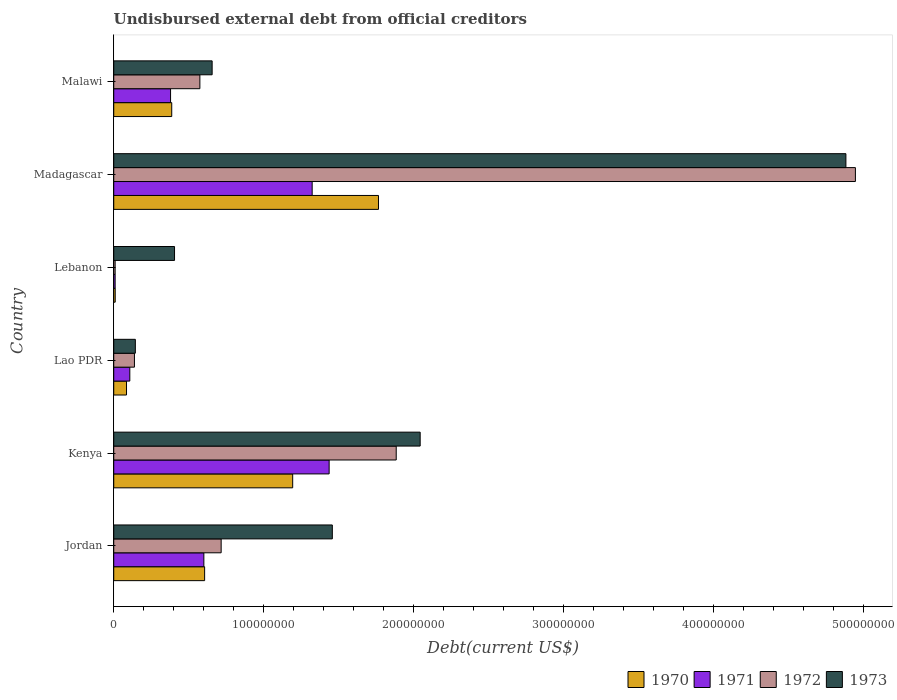How many different coloured bars are there?
Offer a terse response. 4. Are the number of bars on each tick of the Y-axis equal?
Keep it short and to the point. Yes. How many bars are there on the 2nd tick from the top?
Your response must be concise. 4. What is the label of the 2nd group of bars from the top?
Provide a succinct answer. Madagascar. In how many cases, is the number of bars for a given country not equal to the number of legend labels?
Provide a succinct answer. 0. What is the total debt in 1970 in Kenya?
Keep it short and to the point. 1.19e+08. Across all countries, what is the maximum total debt in 1970?
Keep it short and to the point. 1.76e+08. Across all countries, what is the minimum total debt in 1971?
Provide a succinct answer. 9.32e+05. In which country was the total debt in 1970 maximum?
Your answer should be compact. Madagascar. In which country was the total debt in 1971 minimum?
Provide a short and direct response. Lebanon. What is the total total debt in 1970 in the graph?
Give a very brief answer. 4.05e+08. What is the difference between the total debt in 1972 in Lao PDR and that in Madagascar?
Give a very brief answer. -4.81e+08. What is the difference between the total debt in 1971 in Kenya and the total debt in 1972 in Lebanon?
Your response must be concise. 1.43e+08. What is the average total debt in 1972 per country?
Ensure brevity in your answer.  1.38e+08. What is the difference between the total debt in 1970 and total debt in 1973 in Jordan?
Keep it short and to the point. -8.51e+07. What is the ratio of the total debt in 1971 in Jordan to that in Lebanon?
Make the answer very short. 64.46. What is the difference between the highest and the second highest total debt in 1970?
Make the answer very short. 5.72e+07. What is the difference between the highest and the lowest total debt in 1973?
Your answer should be very brief. 4.74e+08. In how many countries, is the total debt in 1972 greater than the average total debt in 1972 taken over all countries?
Keep it short and to the point. 2. What does the 3rd bar from the top in Malawi represents?
Provide a short and direct response. 1971. Are all the bars in the graph horizontal?
Give a very brief answer. Yes. How many countries are there in the graph?
Your answer should be very brief. 6. What is the difference between two consecutive major ticks on the X-axis?
Ensure brevity in your answer.  1.00e+08. Are the values on the major ticks of X-axis written in scientific E-notation?
Provide a succinct answer. No. Does the graph contain any zero values?
Your answer should be compact. No. Where does the legend appear in the graph?
Make the answer very short. Bottom right. What is the title of the graph?
Make the answer very short. Undisbursed external debt from official creditors. Does "1986" appear as one of the legend labels in the graph?
Your answer should be very brief. No. What is the label or title of the X-axis?
Your answer should be compact. Debt(current US$). What is the Debt(current US$) of 1970 in Jordan?
Offer a terse response. 6.06e+07. What is the Debt(current US$) in 1971 in Jordan?
Ensure brevity in your answer.  6.01e+07. What is the Debt(current US$) in 1972 in Jordan?
Give a very brief answer. 7.16e+07. What is the Debt(current US$) in 1973 in Jordan?
Give a very brief answer. 1.46e+08. What is the Debt(current US$) of 1970 in Kenya?
Keep it short and to the point. 1.19e+08. What is the Debt(current US$) in 1971 in Kenya?
Provide a succinct answer. 1.44e+08. What is the Debt(current US$) of 1972 in Kenya?
Your response must be concise. 1.88e+08. What is the Debt(current US$) in 1973 in Kenya?
Give a very brief answer. 2.04e+08. What is the Debt(current US$) in 1970 in Lao PDR?
Ensure brevity in your answer.  8.52e+06. What is the Debt(current US$) in 1971 in Lao PDR?
Your answer should be compact. 1.07e+07. What is the Debt(current US$) of 1972 in Lao PDR?
Give a very brief answer. 1.38e+07. What is the Debt(current US$) of 1973 in Lao PDR?
Offer a very short reply. 1.44e+07. What is the Debt(current US$) of 1970 in Lebanon?
Offer a very short reply. 9.80e+05. What is the Debt(current US$) in 1971 in Lebanon?
Your response must be concise. 9.32e+05. What is the Debt(current US$) in 1972 in Lebanon?
Provide a short and direct response. 9.32e+05. What is the Debt(current US$) in 1973 in Lebanon?
Provide a short and direct response. 4.05e+07. What is the Debt(current US$) in 1970 in Madagascar?
Provide a short and direct response. 1.76e+08. What is the Debt(current US$) in 1971 in Madagascar?
Give a very brief answer. 1.32e+08. What is the Debt(current US$) of 1972 in Madagascar?
Ensure brevity in your answer.  4.94e+08. What is the Debt(current US$) in 1973 in Madagascar?
Your answer should be compact. 4.88e+08. What is the Debt(current US$) in 1970 in Malawi?
Your response must be concise. 3.87e+07. What is the Debt(current US$) of 1971 in Malawi?
Provide a succinct answer. 3.79e+07. What is the Debt(current US$) of 1972 in Malawi?
Provide a short and direct response. 5.74e+07. What is the Debt(current US$) in 1973 in Malawi?
Offer a very short reply. 6.56e+07. Across all countries, what is the maximum Debt(current US$) of 1970?
Make the answer very short. 1.76e+08. Across all countries, what is the maximum Debt(current US$) in 1971?
Offer a very short reply. 1.44e+08. Across all countries, what is the maximum Debt(current US$) in 1972?
Your answer should be compact. 4.94e+08. Across all countries, what is the maximum Debt(current US$) of 1973?
Your response must be concise. 4.88e+08. Across all countries, what is the minimum Debt(current US$) of 1970?
Give a very brief answer. 9.80e+05. Across all countries, what is the minimum Debt(current US$) of 1971?
Your response must be concise. 9.32e+05. Across all countries, what is the minimum Debt(current US$) of 1972?
Ensure brevity in your answer.  9.32e+05. Across all countries, what is the minimum Debt(current US$) of 1973?
Your answer should be very brief. 1.44e+07. What is the total Debt(current US$) in 1970 in the graph?
Provide a short and direct response. 4.05e+08. What is the total Debt(current US$) in 1971 in the graph?
Offer a very short reply. 3.85e+08. What is the total Debt(current US$) of 1972 in the graph?
Keep it short and to the point. 8.27e+08. What is the total Debt(current US$) of 1973 in the graph?
Provide a succinct answer. 9.59e+08. What is the difference between the Debt(current US$) of 1970 in Jordan and that in Kenya?
Ensure brevity in your answer.  -5.87e+07. What is the difference between the Debt(current US$) in 1971 in Jordan and that in Kenya?
Your response must be concise. -8.35e+07. What is the difference between the Debt(current US$) of 1972 in Jordan and that in Kenya?
Provide a succinct answer. -1.17e+08. What is the difference between the Debt(current US$) in 1973 in Jordan and that in Kenya?
Your answer should be compact. -5.86e+07. What is the difference between the Debt(current US$) of 1970 in Jordan and that in Lao PDR?
Offer a very short reply. 5.21e+07. What is the difference between the Debt(current US$) of 1971 in Jordan and that in Lao PDR?
Give a very brief answer. 4.94e+07. What is the difference between the Debt(current US$) of 1972 in Jordan and that in Lao PDR?
Give a very brief answer. 5.78e+07. What is the difference between the Debt(current US$) in 1973 in Jordan and that in Lao PDR?
Offer a terse response. 1.31e+08. What is the difference between the Debt(current US$) of 1970 in Jordan and that in Lebanon?
Give a very brief answer. 5.96e+07. What is the difference between the Debt(current US$) in 1971 in Jordan and that in Lebanon?
Provide a succinct answer. 5.91e+07. What is the difference between the Debt(current US$) in 1972 in Jordan and that in Lebanon?
Offer a very short reply. 7.07e+07. What is the difference between the Debt(current US$) in 1973 in Jordan and that in Lebanon?
Provide a succinct answer. 1.05e+08. What is the difference between the Debt(current US$) of 1970 in Jordan and that in Madagascar?
Your response must be concise. -1.16e+08. What is the difference between the Debt(current US$) of 1971 in Jordan and that in Madagascar?
Keep it short and to the point. -7.22e+07. What is the difference between the Debt(current US$) in 1972 in Jordan and that in Madagascar?
Ensure brevity in your answer.  -4.23e+08. What is the difference between the Debt(current US$) in 1973 in Jordan and that in Madagascar?
Ensure brevity in your answer.  -3.42e+08. What is the difference between the Debt(current US$) in 1970 in Jordan and that in Malawi?
Ensure brevity in your answer.  2.19e+07. What is the difference between the Debt(current US$) of 1971 in Jordan and that in Malawi?
Your answer should be compact. 2.22e+07. What is the difference between the Debt(current US$) of 1972 in Jordan and that in Malawi?
Offer a terse response. 1.42e+07. What is the difference between the Debt(current US$) of 1973 in Jordan and that in Malawi?
Your answer should be compact. 8.01e+07. What is the difference between the Debt(current US$) of 1970 in Kenya and that in Lao PDR?
Your response must be concise. 1.11e+08. What is the difference between the Debt(current US$) in 1971 in Kenya and that in Lao PDR?
Your answer should be compact. 1.33e+08. What is the difference between the Debt(current US$) in 1972 in Kenya and that in Lao PDR?
Offer a very short reply. 1.75e+08. What is the difference between the Debt(current US$) of 1973 in Kenya and that in Lao PDR?
Ensure brevity in your answer.  1.90e+08. What is the difference between the Debt(current US$) in 1970 in Kenya and that in Lebanon?
Ensure brevity in your answer.  1.18e+08. What is the difference between the Debt(current US$) of 1971 in Kenya and that in Lebanon?
Your answer should be very brief. 1.43e+08. What is the difference between the Debt(current US$) of 1972 in Kenya and that in Lebanon?
Offer a very short reply. 1.87e+08. What is the difference between the Debt(current US$) of 1973 in Kenya and that in Lebanon?
Provide a succinct answer. 1.64e+08. What is the difference between the Debt(current US$) in 1970 in Kenya and that in Madagascar?
Your answer should be very brief. -5.72e+07. What is the difference between the Debt(current US$) of 1971 in Kenya and that in Madagascar?
Your answer should be compact. 1.13e+07. What is the difference between the Debt(current US$) in 1972 in Kenya and that in Madagascar?
Provide a succinct answer. -3.06e+08. What is the difference between the Debt(current US$) in 1973 in Kenya and that in Madagascar?
Offer a terse response. -2.84e+08. What is the difference between the Debt(current US$) in 1970 in Kenya and that in Malawi?
Provide a succinct answer. 8.06e+07. What is the difference between the Debt(current US$) of 1971 in Kenya and that in Malawi?
Give a very brief answer. 1.06e+08. What is the difference between the Debt(current US$) of 1972 in Kenya and that in Malawi?
Keep it short and to the point. 1.31e+08. What is the difference between the Debt(current US$) of 1973 in Kenya and that in Malawi?
Your answer should be compact. 1.39e+08. What is the difference between the Debt(current US$) of 1970 in Lao PDR and that in Lebanon?
Your answer should be compact. 7.54e+06. What is the difference between the Debt(current US$) of 1971 in Lao PDR and that in Lebanon?
Your answer should be very brief. 9.78e+06. What is the difference between the Debt(current US$) of 1972 in Lao PDR and that in Lebanon?
Provide a short and direct response. 1.29e+07. What is the difference between the Debt(current US$) of 1973 in Lao PDR and that in Lebanon?
Your answer should be very brief. -2.61e+07. What is the difference between the Debt(current US$) of 1970 in Lao PDR and that in Madagascar?
Offer a very short reply. -1.68e+08. What is the difference between the Debt(current US$) of 1971 in Lao PDR and that in Madagascar?
Provide a short and direct response. -1.22e+08. What is the difference between the Debt(current US$) of 1972 in Lao PDR and that in Madagascar?
Offer a very short reply. -4.81e+08. What is the difference between the Debt(current US$) of 1973 in Lao PDR and that in Madagascar?
Your answer should be very brief. -4.74e+08. What is the difference between the Debt(current US$) in 1970 in Lao PDR and that in Malawi?
Make the answer very short. -3.01e+07. What is the difference between the Debt(current US$) of 1971 in Lao PDR and that in Malawi?
Give a very brief answer. -2.72e+07. What is the difference between the Debt(current US$) in 1972 in Lao PDR and that in Malawi?
Keep it short and to the point. -4.36e+07. What is the difference between the Debt(current US$) in 1973 in Lao PDR and that in Malawi?
Offer a very short reply. -5.12e+07. What is the difference between the Debt(current US$) of 1970 in Lebanon and that in Madagascar?
Ensure brevity in your answer.  -1.76e+08. What is the difference between the Debt(current US$) in 1971 in Lebanon and that in Madagascar?
Provide a succinct answer. -1.31e+08. What is the difference between the Debt(current US$) in 1972 in Lebanon and that in Madagascar?
Provide a succinct answer. -4.94e+08. What is the difference between the Debt(current US$) of 1973 in Lebanon and that in Madagascar?
Make the answer very short. -4.48e+08. What is the difference between the Debt(current US$) of 1970 in Lebanon and that in Malawi?
Provide a short and direct response. -3.77e+07. What is the difference between the Debt(current US$) in 1971 in Lebanon and that in Malawi?
Your response must be concise. -3.70e+07. What is the difference between the Debt(current US$) in 1972 in Lebanon and that in Malawi?
Your answer should be compact. -5.65e+07. What is the difference between the Debt(current US$) in 1973 in Lebanon and that in Malawi?
Offer a very short reply. -2.51e+07. What is the difference between the Debt(current US$) in 1970 in Madagascar and that in Malawi?
Your answer should be compact. 1.38e+08. What is the difference between the Debt(current US$) in 1971 in Madagascar and that in Malawi?
Provide a short and direct response. 9.44e+07. What is the difference between the Debt(current US$) of 1972 in Madagascar and that in Malawi?
Your response must be concise. 4.37e+08. What is the difference between the Debt(current US$) of 1973 in Madagascar and that in Malawi?
Provide a succinct answer. 4.23e+08. What is the difference between the Debt(current US$) in 1970 in Jordan and the Debt(current US$) in 1971 in Kenya?
Your response must be concise. -8.30e+07. What is the difference between the Debt(current US$) of 1970 in Jordan and the Debt(current US$) of 1972 in Kenya?
Ensure brevity in your answer.  -1.28e+08. What is the difference between the Debt(current US$) of 1970 in Jordan and the Debt(current US$) of 1973 in Kenya?
Keep it short and to the point. -1.44e+08. What is the difference between the Debt(current US$) of 1971 in Jordan and the Debt(current US$) of 1972 in Kenya?
Offer a very short reply. -1.28e+08. What is the difference between the Debt(current US$) in 1971 in Jordan and the Debt(current US$) in 1973 in Kenya?
Offer a terse response. -1.44e+08. What is the difference between the Debt(current US$) in 1972 in Jordan and the Debt(current US$) in 1973 in Kenya?
Keep it short and to the point. -1.33e+08. What is the difference between the Debt(current US$) of 1970 in Jordan and the Debt(current US$) of 1971 in Lao PDR?
Your answer should be very brief. 4.99e+07. What is the difference between the Debt(current US$) in 1970 in Jordan and the Debt(current US$) in 1972 in Lao PDR?
Provide a succinct answer. 4.68e+07. What is the difference between the Debt(current US$) in 1970 in Jordan and the Debt(current US$) in 1973 in Lao PDR?
Offer a very short reply. 4.62e+07. What is the difference between the Debt(current US$) of 1971 in Jordan and the Debt(current US$) of 1972 in Lao PDR?
Offer a terse response. 4.63e+07. What is the difference between the Debt(current US$) of 1971 in Jordan and the Debt(current US$) of 1973 in Lao PDR?
Give a very brief answer. 4.57e+07. What is the difference between the Debt(current US$) in 1972 in Jordan and the Debt(current US$) in 1973 in Lao PDR?
Ensure brevity in your answer.  5.72e+07. What is the difference between the Debt(current US$) of 1970 in Jordan and the Debt(current US$) of 1971 in Lebanon?
Your answer should be very brief. 5.97e+07. What is the difference between the Debt(current US$) of 1970 in Jordan and the Debt(current US$) of 1972 in Lebanon?
Make the answer very short. 5.97e+07. What is the difference between the Debt(current US$) in 1970 in Jordan and the Debt(current US$) in 1973 in Lebanon?
Provide a short and direct response. 2.01e+07. What is the difference between the Debt(current US$) of 1971 in Jordan and the Debt(current US$) of 1972 in Lebanon?
Give a very brief answer. 5.91e+07. What is the difference between the Debt(current US$) in 1971 in Jordan and the Debt(current US$) in 1973 in Lebanon?
Your answer should be compact. 1.95e+07. What is the difference between the Debt(current US$) in 1972 in Jordan and the Debt(current US$) in 1973 in Lebanon?
Make the answer very short. 3.11e+07. What is the difference between the Debt(current US$) of 1970 in Jordan and the Debt(current US$) of 1971 in Madagascar?
Provide a succinct answer. -7.17e+07. What is the difference between the Debt(current US$) of 1970 in Jordan and the Debt(current US$) of 1972 in Madagascar?
Make the answer very short. -4.34e+08. What is the difference between the Debt(current US$) in 1970 in Jordan and the Debt(current US$) in 1973 in Madagascar?
Provide a short and direct response. -4.28e+08. What is the difference between the Debt(current US$) in 1971 in Jordan and the Debt(current US$) in 1972 in Madagascar?
Offer a very short reply. -4.34e+08. What is the difference between the Debt(current US$) in 1971 in Jordan and the Debt(current US$) in 1973 in Madagascar?
Your answer should be compact. -4.28e+08. What is the difference between the Debt(current US$) in 1972 in Jordan and the Debt(current US$) in 1973 in Madagascar?
Ensure brevity in your answer.  -4.17e+08. What is the difference between the Debt(current US$) in 1970 in Jordan and the Debt(current US$) in 1971 in Malawi?
Your answer should be very brief. 2.27e+07. What is the difference between the Debt(current US$) of 1970 in Jordan and the Debt(current US$) of 1972 in Malawi?
Ensure brevity in your answer.  3.17e+06. What is the difference between the Debt(current US$) of 1970 in Jordan and the Debt(current US$) of 1973 in Malawi?
Your response must be concise. -5.00e+06. What is the difference between the Debt(current US$) in 1971 in Jordan and the Debt(current US$) in 1972 in Malawi?
Provide a short and direct response. 2.65e+06. What is the difference between the Debt(current US$) of 1971 in Jordan and the Debt(current US$) of 1973 in Malawi?
Provide a succinct answer. -5.52e+06. What is the difference between the Debt(current US$) in 1972 in Jordan and the Debt(current US$) in 1973 in Malawi?
Keep it short and to the point. 6.01e+06. What is the difference between the Debt(current US$) in 1970 in Kenya and the Debt(current US$) in 1971 in Lao PDR?
Keep it short and to the point. 1.09e+08. What is the difference between the Debt(current US$) of 1970 in Kenya and the Debt(current US$) of 1972 in Lao PDR?
Offer a very short reply. 1.05e+08. What is the difference between the Debt(current US$) of 1970 in Kenya and the Debt(current US$) of 1973 in Lao PDR?
Keep it short and to the point. 1.05e+08. What is the difference between the Debt(current US$) in 1971 in Kenya and the Debt(current US$) in 1972 in Lao PDR?
Ensure brevity in your answer.  1.30e+08. What is the difference between the Debt(current US$) in 1971 in Kenya and the Debt(current US$) in 1973 in Lao PDR?
Keep it short and to the point. 1.29e+08. What is the difference between the Debt(current US$) of 1972 in Kenya and the Debt(current US$) of 1973 in Lao PDR?
Ensure brevity in your answer.  1.74e+08. What is the difference between the Debt(current US$) of 1970 in Kenya and the Debt(current US$) of 1971 in Lebanon?
Provide a succinct answer. 1.18e+08. What is the difference between the Debt(current US$) in 1970 in Kenya and the Debt(current US$) in 1972 in Lebanon?
Offer a terse response. 1.18e+08. What is the difference between the Debt(current US$) in 1970 in Kenya and the Debt(current US$) in 1973 in Lebanon?
Your answer should be compact. 7.88e+07. What is the difference between the Debt(current US$) in 1971 in Kenya and the Debt(current US$) in 1972 in Lebanon?
Your response must be concise. 1.43e+08. What is the difference between the Debt(current US$) of 1971 in Kenya and the Debt(current US$) of 1973 in Lebanon?
Provide a succinct answer. 1.03e+08. What is the difference between the Debt(current US$) in 1972 in Kenya and the Debt(current US$) in 1973 in Lebanon?
Your answer should be very brief. 1.48e+08. What is the difference between the Debt(current US$) in 1970 in Kenya and the Debt(current US$) in 1971 in Madagascar?
Your response must be concise. -1.30e+07. What is the difference between the Debt(current US$) in 1970 in Kenya and the Debt(current US$) in 1972 in Madagascar?
Your answer should be very brief. -3.75e+08. What is the difference between the Debt(current US$) in 1970 in Kenya and the Debt(current US$) in 1973 in Madagascar?
Offer a very short reply. -3.69e+08. What is the difference between the Debt(current US$) of 1971 in Kenya and the Debt(current US$) of 1972 in Madagascar?
Keep it short and to the point. -3.51e+08. What is the difference between the Debt(current US$) of 1971 in Kenya and the Debt(current US$) of 1973 in Madagascar?
Your answer should be compact. -3.45e+08. What is the difference between the Debt(current US$) in 1972 in Kenya and the Debt(current US$) in 1973 in Madagascar?
Offer a very short reply. -3.00e+08. What is the difference between the Debt(current US$) of 1970 in Kenya and the Debt(current US$) of 1971 in Malawi?
Make the answer very short. 8.14e+07. What is the difference between the Debt(current US$) in 1970 in Kenya and the Debt(current US$) in 1972 in Malawi?
Give a very brief answer. 6.19e+07. What is the difference between the Debt(current US$) in 1970 in Kenya and the Debt(current US$) in 1973 in Malawi?
Offer a very short reply. 5.37e+07. What is the difference between the Debt(current US$) of 1971 in Kenya and the Debt(current US$) of 1972 in Malawi?
Make the answer very short. 8.62e+07. What is the difference between the Debt(current US$) of 1971 in Kenya and the Debt(current US$) of 1973 in Malawi?
Offer a terse response. 7.80e+07. What is the difference between the Debt(current US$) in 1972 in Kenya and the Debt(current US$) in 1973 in Malawi?
Your answer should be very brief. 1.23e+08. What is the difference between the Debt(current US$) of 1970 in Lao PDR and the Debt(current US$) of 1971 in Lebanon?
Keep it short and to the point. 7.59e+06. What is the difference between the Debt(current US$) of 1970 in Lao PDR and the Debt(current US$) of 1972 in Lebanon?
Your answer should be compact. 7.59e+06. What is the difference between the Debt(current US$) in 1970 in Lao PDR and the Debt(current US$) in 1973 in Lebanon?
Make the answer very short. -3.20e+07. What is the difference between the Debt(current US$) in 1971 in Lao PDR and the Debt(current US$) in 1972 in Lebanon?
Offer a very short reply. 9.78e+06. What is the difference between the Debt(current US$) in 1971 in Lao PDR and the Debt(current US$) in 1973 in Lebanon?
Ensure brevity in your answer.  -2.98e+07. What is the difference between the Debt(current US$) of 1972 in Lao PDR and the Debt(current US$) of 1973 in Lebanon?
Provide a short and direct response. -2.67e+07. What is the difference between the Debt(current US$) in 1970 in Lao PDR and the Debt(current US$) in 1971 in Madagascar?
Provide a succinct answer. -1.24e+08. What is the difference between the Debt(current US$) in 1970 in Lao PDR and the Debt(current US$) in 1972 in Madagascar?
Provide a short and direct response. -4.86e+08. What is the difference between the Debt(current US$) of 1970 in Lao PDR and the Debt(current US$) of 1973 in Madagascar?
Make the answer very short. -4.80e+08. What is the difference between the Debt(current US$) in 1971 in Lao PDR and the Debt(current US$) in 1972 in Madagascar?
Your response must be concise. -4.84e+08. What is the difference between the Debt(current US$) in 1971 in Lao PDR and the Debt(current US$) in 1973 in Madagascar?
Offer a terse response. -4.77e+08. What is the difference between the Debt(current US$) of 1972 in Lao PDR and the Debt(current US$) of 1973 in Madagascar?
Make the answer very short. -4.74e+08. What is the difference between the Debt(current US$) in 1970 in Lao PDR and the Debt(current US$) in 1971 in Malawi?
Offer a very short reply. -2.94e+07. What is the difference between the Debt(current US$) of 1970 in Lao PDR and the Debt(current US$) of 1972 in Malawi?
Your answer should be very brief. -4.89e+07. What is the difference between the Debt(current US$) of 1970 in Lao PDR and the Debt(current US$) of 1973 in Malawi?
Give a very brief answer. -5.71e+07. What is the difference between the Debt(current US$) of 1971 in Lao PDR and the Debt(current US$) of 1972 in Malawi?
Your answer should be compact. -4.67e+07. What is the difference between the Debt(current US$) in 1971 in Lao PDR and the Debt(current US$) in 1973 in Malawi?
Provide a short and direct response. -5.49e+07. What is the difference between the Debt(current US$) of 1972 in Lao PDR and the Debt(current US$) of 1973 in Malawi?
Ensure brevity in your answer.  -5.18e+07. What is the difference between the Debt(current US$) of 1970 in Lebanon and the Debt(current US$) of 1971 in Madagascar?
Your response must be concise. -1.31e+08. What is the difference between the Debt(current US$) of 1970 in Lebanon and the Debt(current US$) of 1972 in Madagascar?
Provide a succinct answer. -4.93e+08. What is the difference between the Debt(current US$) of 1970 in Lebanon and the Debt(current US$) of 1973 in Madagascar?
Your response must be concise. -4.87e+08. What is the difference between the Debt(current US$) in 1971 in Lebanon and the Debt(current US$) in 1972 in Madagascar?
Make the answer very short. -4.94e+08. What is the difference between the Debt(current US$) in 1971 in Lebanon and the Debt(current US$) in 1973 in Madagascar?
Ensure brevity in your answer.  -4.87e+08. What is the difference between the Debt(current US$) of 1972 in Lebanon and the Debt(current US$) of 1973 in Madagascar?
Your answer should be very brief. -4.87e+08. What is the difference between the Debt(current US$) in 1970 in Lebanon and the Debt(current US$) in 1971 in Malawi?
Make the answer very short. -3.69e+07. What is the difference between the Debt(current US$) in 1970 in Lebanon and the Debt(current US$) in 1972 in Malawi?
Provide a succinct answer. -5.64e+07. What is the difference between the Debt(current US$) in 1970 in Lebanon and the Debt(current US$) in 1973 in Malawi?
Your answer should be very brief. -6.46e+07. What is the difference between the Debt(current US$) in 1971 in Lebanon and the Debt(current US$) in 1972 in Malawi?
Provide a succinct answer. -5.65e+07. What is the difference between the Debt(current US$) of 1971 in Lebanon and the Debt(current US$) of 1973 in Malawi?
Offer a terse response. -6.47e+07. What is the difference between the Debt(current US$) of 1972 in Lebanon and the Debt(current US$) of 1973 in Malawi?
Give a very brief answer. -6.47e+07. What is the difference between the Debt(current US$) in 1970 in Madagascar and the Debt(current US$) in 1971 in Malawi?
Provide a succinct answer. 1.39e+08. What is the difference between the Debt(current US$) in 1970 in Madagascar and the Debt(current US$) in 1972 in Malawi?
Offer a very short reply. 1.19e+08. What is the difference between the Debt(current US$) of 1970 in Madagascar and the Debt(current US$) of 1973 in Malawi?
Your answer should be very brief. 1.11e+08. What is the difference between the Debt(current US$) of 1971 in Madagascar and the Debt(current US$) of 1972 in Malawi?
Your answer should be very brief. 7.49e+07. What is the difference between the Debt(current US$) of 1971 in Madagascar and the Debt(current US$) of 1973 in Malawi?
Make the answer very short. 6.67e+07. What is the difference between the Debt(current US$) in 1972 in Madagascar and the Debt(current US$) in 1973 in Malawi?
Provide a short and direct response. 4.29e+08. What is the average Debt(current US$) of 1970 per country?
Ensure brevity in your answer.  6.74e+07. What is the average Debt(current US$) in 1971 per country?
Your response must be concise. 6.42e+07. What is the average Debt(current US$) of 1972 per country?
Your response must be concise. 1.38e+08. What is the average Debt(current US$) in 1973 per country?
Offer a very short reply. 1.60e+08. What is the difference between the Debt(current US$) of 1970 and Debt(current US$) of 1971 in Jordan?
Give a very brief answer. 5.19e+05. What is the difference between the Debt(current US$) of 1970 and Debt(current US$) of 1972 in Jordan?
Give a very brief answer. -1.10e+07. What is the difference between the Debt(current US$) of 1970 and Debt(current US$) of 1973 in Jordan?
Your response must be concise. -8.51e+07. What is the difference between the Debt(current US$) in 1971 and Debt(current US$) in 1972 in Jordan?
Your response must be concise. -1.15e+07. What is the difference between the Debt(current US$) of 1971 and Debt(current US$) of 1973 in Jordan?
Offer a terse response. -8.57e+07. What is the difference between the Debt(current US$) in 1972 and Debt(current US$) in 1973 in Jordan?
Offer a terse response. -7.41e+07. What is the difference between the Debt(current US$) in 1970 and Debt(current US$) in 1971 in Kenya?
Provide a short and direct response. -2.43e+07. What is the difference between the Debt(current US$) in 1970 and Debt(current US$) in 1972 in Kenya?
Make the answer very short. -6.90e+07. What is the difference between the Debt(current US$) in 1970 and Debt(current US$) in 1973 in Kenya?
Keep it short and to the point. -8.50e+07. What is the difference between the Debt(current US$) in 1971 and Debt(current US$) in 1972 in Kenya?
Your answer should be compact. -4.47e+07. What is the difference between the Debt(current US$) in 1971 and Debt(current US$) in 1973 in Kenya?
Your answer should be compact. -6.07e+07. What is the difference between the Debt(current US$) in 1972 and Debt(current US$) in 1973 in Kenya?
Provide a succinct answer. -1.60e+07. What is the difference between the Debt(current US$) in 1970 and Debt(current US$) in 1971 in Lao PDR?
Give a very brief answer. -2.19e+06. What is the difference between the Debt(current US$) in 1970 and Debt(current US$) in 1972 in Lao PDR?
Ensure brevity in your answer.  -5.28e+06. What is the difference between the Debt(current US$) of 1970 and Debt(current US$) of 1973 in Lao PDR?
Your response must be concise. -5.88e+06. What is the difference between the Debt(current US$) of 1971 and Debt(current US$) of 1972 in Lao PDR?
Ensure brevity in your answer.  -3.08e+06. What is the difference between the Debt(current US$) of 1971 and Debt(current US$) of 1973 in Lao PDR?
Provide a short and direct response. -3.69e+06. What is the difference between the Debt(current US$) of 1972 and Debt(current US$) of 1973 in Lao PDR?
Offer a terse response. -6.01e+05. What is the difference between the Debt(current US$) in 1970 and Debt(current US$) in 1971 in Lebanon?
Ensure brevity in your answer.  4.80e+04. What is the difference between the Debt(current US$) in 1970 and Debt(current US$) in 1972 in Lebanon?
Offer a very short reply. 4.80e+04. What is the difference between the Debt(current US$) in 1970 and Debt(current US$) in 1973 in Lebanon?
Keep it short and to the point. -3.96e+07. What is the difference between the Debt(current US$) in 1971 and Debt(current US$) in 1972 in Lebanon?
Your answer should be compact. 0. What is the difference between the Debt(current US$) of 1971 and Debt(current US$) of 1973 in Lebanon?
Your response must be concise. -3.96e+07. What is the difference between the Debt(current US$) of 1972 and Debt(current US$) of 1973 in Lebanon?
Ensure brevity in your answer.  -3.96e+07. What is the difference between the Debt(current US$) of 1970 and Debt(current US$) of 1971 in Madagascar?
Provide a succinct answer. 4.42e+07. What is the difference between the Debt(current US$) of 1970 and Debt(current US$) of 1972 in Madagascar?
Keep it short and to the point. -3.18e+08. What is the difference between the Debt(current US$) of 1970 and Debt(current US$) of 1973 in Madagascar?
Provide a short and direct response. -3.12e+08. What is the difference between the Debt(current US$) in 1971 and Debt(current US$) in 1972 in Madagascar?
Ensure brevity in your answer.  -3.62e+08. What is the difference between the Debt(current US$) in 1971 and Debt(current US$) in 1973 in Madagascar?
Make the answer very short. -3.56e+08. What is the difference between the Debt(current US$) in 1972 and Debt(current US$) in 1973 in Madagascar?
Your response must be concise. 6.33e+06. What is the difference between the Debt(current US$) of 1970 and Debt(current US$) of 1971 in Malawi?
Give a very brief answer. 7.85e+05. What is the difference between the Debt(current US$) of 1970 and Debt(current US$) of 1972 in Malawi?
Make the answer very short. -1.88e+07. What is the difference between the Debt(current US$) of 1970 and Debt(current US$) of 1973 in Malawi?
Your response must be concise. -2.69e+07. What is the difference between the Debt(current US$) of 1971 and Debt(current US$) of 1972 in Malawi?
Offer a terse response. -1.95e+07. What is the difference between the Debt(current US$) of 1971 and Debt(current US$) of 1973 in Malawi?
Your answer should be compact. -2.77e+07. What is the difference between the Debt(current US$) in 1972 and Debt(current US$) in 1973 in Malawi?
Ensure brevity in your answer.  -8.17e+06. What is the ratio of the Debt(current US$) of 1970 in Jordan to that in Kenya?
Offer a very short reply. 0.51. What is the ratio of the Debt(current US$) in 1971 in Jordan to that in Kenya?
Make the answer very short. 0.42. What is the ratio of the Debt(current US$) of 1972 in Jordan to that in Kenya?
Ensure brevity in your answer.  0.38. What is the ratio of the Debt(current US$) in 1973 in Jordan to that in Kenya?
Your answer should be compact. 0.71. What is the ratio of the Debt(current US$) of 1970 in Jordan to that in Lao PDR?
Offer a very short reply. 7.11. What is the ratio of the Debt(current US$) in 1971 in Jordan to that in Lao PDR?
Your answer should be compact. 5.61. What is the ratio of the Debt(current US$) in 1972 in Jordan to that in Lao PDR?
Keep it short and to the point. 5.19. What is the ratio of the Debt(current US$) in 1973 in Jordan to that in Lao PDR?
Provide a short and direct response. 10.12. What is the ratio of the Debt(current US$) in 1970 in Jordan to that in Lebanon?
Offer a terse response. 61.83. What is the ratio of the Debt(current US$) in 1971 in Jordan to that in Lebanon?
Your answer should be very brief. 64.46. What is the ratio of the Debt(current US$) of 1972 in Jordan to that in Lebanon?
Give a very brief answer. 76.83. What is the ratio of the Debt(current US$) of 1973 in Jordan to that in Lebanon?
Provide a succinct answer. 3.6. What is the ratio of the Debt(current US$) of 1970 in Jordan to that in Madagascar?
Give a very brief answer. 0.34. What is the ratio of the Debt(current US$) in 1971 in Jordan to that in Madagascar?
Keep it short and to the point. 0.45. What is the ratio of the Debt(current US$) of 1972 in Jordan to that in Madagascar?
Offer a terse response. 0.14. What is the ratio of the Debt(current US$) of 1973 in Jordan to that in Madagascar?
Give a very brief answer. 0.3. What is the ratio of the Debt(current US$) in 1970 in Jordan to that in Malawi?
Your answer should be very brief. 1.57. What is the ratio of the Debt(current US$) in 1971 in Jordan to that in Malawi?
Give a very brief answer. 1.59. What is the ratio of the Debt(current US$) of 1972 in Jordan to that in Malawi?
Your answer should be very brief. 1.25. What is the ratio of the Debt(current US$) in 1973 in Jordan to that in Malawi?
Your answer should be compact. 2.22. What is the ratio of the Debt(current US$) in 1970 in Kenya to that in Lao PDR?
Offer a terse response. 14. What is the ratio of the Debt(current US$) in 1971 in Kenya to that in Lao PDR?
Your response must be concise. 13.41. What is the ratio of the Debt(current US$) of 1972 in Kenya to that in Lao PDR?
Make the answer very short. 13.65. What is the ratio of the Debt(current US$) of 1973 in Kenya to that in Lao PDR?
Offer a terse response. 14.19. What is the ratio of the Debt(current US$) of 1970 in Kenya to that in Lebanon?
Ensure brevity in your answer.  121.73. What is the ratio of the Debt(current US$) of 1971 in Kenya to that in Lebanon?
Ensure brevity in your answer.  154.08. What is the ratio of the Debt(current US$) in 1972 in Kenya to that in Lebanon?
Provide a succinct answer. 202.06. What is the ratio of the Debt(current US$) in 1973 in Kenya to that in Lebanon?
Provide a succinct answer. 5.04. What is the ratio of the Debt(current US$) in 1970 in Kenya to that in Madagascar?
Offer a very short reply. 0.68. What is the ratio of the Debt(current US$) of 1971 in Kenya to that in Madagascar?
Provide a short and direct response. 1.09. What is the ratio of the Debt(current US$) in 1972 in Kenya to that in Madagascar?
Provide a succinct answer. 0.38. What is the ratio of the Debt(current US$) of 1973 in Kenya to that in Madagascar?
Make the answer very short. 0.42. What is the ratio of the Debt(current US$) in 1970 in Kenya to that in Malawi?
Offer a very short reply. 3.09. What is the ratio of the Debt(current US$) of 1971 in Kenya to that in Malawi?
Keep it short and to the point. 3.79. What is the ratio of the Debt(current US$) in 1972 in Kenya to that in Malawi?
Ensure brevity in your answer.  3.28. What is the ratio of the Debt(current US$) in 1973 in Kenya to that in Malawi?
Provide a succinct answer. 3.11. What is the ratio of the Debt(current US$) of 1970 in Lao PDR to that in Lebanon?
Offer a very short reply. 8.69. What is the ratio of the Debt(current US$) in 1971 in Lao PDR to that in Lebanon?
Provide a short and direct response. 11.49. What is the ratio of the Debt(current US$) of 1972 in Lao PDR to that in Lebanon?
Ensure brevity in your answer.  14.8. What is the ratio of the Debt(current US$) in 1973 in Lao PDR to that in Lebanon?
Provide a succinct answer. 0.36. What is the ratio of the Debt(current US$) of 1970 in Lao PDR to that in Madagascar?
Offer a terse response. 0.05. What is the ratio of the Debt(current US$) of 1971 in Lao PDR to that in Madagascar?
Give a very brief answer. 0.08. What is the ratio of the Debt(current US$) in 1972 in Lao PDR to that in Madagascar?
Provide a short and direct response. 0.03. What is the ratio of the Debt(current US$) in 1973 in Lao PDR to that in Madagascar?
Keep it short and to the point. 0.03. What is the ratio of the Debt(current US$) in 1970 in Lao PDR to that in Malawi?
Give a very brief answer. 0.22. What is the ratio of the Debt(current US$) in 1971 in Lao PDR to that in Malawi?
Provide a short and direct response. 0.28. What is the ratio of the Debt(current US$) in 1972 in Lao PDR to that in Malawi?
Your answer should be compact. 0.24. What is the ratio of the Debt(current US$) in 1973 in Lao PDR to that in Malawi?
Make the answer very short. 0.22. What is the ratio of the Debt(current US$) in 1970 in Lebanon to that in Madagascar?
Give a very brief answer. 0.01. What is the ratio of the Debt(current US$) of 1971 in Lebanon to that in Madagascar?
Your answer should be very brief. 0.01. What is the ratio of the Debt(current US$) of 1972 in Lebanon to that in Madagascar?
Provide a short and direct response. 0. What is the ratio of the Debt(current US$) in 1973 in Lebanon to that in Madagascar?
Keep it short and to the point. 0.08. What is the ratio of the Debt(current US$) in 1970 in Lebanon to that in Malawi?
Provide a succinct answer. 0.03. What is the ratio of the Debt(current US$) of 1971 in Lebanon to that in Malawi?
Make the answer very short. 0.02. What is the ratio of the Debt(current US$) of 1972 in Lebanon to that in Malawi?
Your response must be concise. 0.02. What is the ratio of the Debt(current US$) in 1973 in Lebanon to that in Malawi?
Ensure brevity in your answer.  0.62. What is the ratio of the Debt(current US$) in 1970 in Madagascar to that in Malawi?
Ensure brevity in your answer.  4.56. What is the ratio of the Debt(current US$) of 1971 in Madagascar to that in Malawi?
Your answer should be compact. 3.49. What is the ratio of the Debt(current US$) in 1972 in Madagascar to that in Malawi?
Keep it short and to the point. 8.61. What is the ratio of the Debt(current US$) in 1973 in Madagascar to that in Malawi?
Your response must be concise. 7.44. What is the difference between the highest and the second highest Debt(current US$) of 1970?
Offer a very short reply. 5.72e+07. What is the difference between the highest and the second highest Debt(current US$) of 1971?
Your response must be concise. 1.13e+07. What is the difference between the highest and the second highest Debt(current US$) in 1972?
Provide a succinct answer. 3.06e+08. What is the difference between the highest and the second highest Debt(current US$) in 1973?
Give a very brief answer. 2.84e+08. What is the difference between the highest and the lowest Debt(current US$) of 1970?
Give a very brief answer. 1.76e+08. What is the difference between the highest and the lowest Debt(current US$) of 1971?
Offer a terse response. 1.43e+08. What is the difference between the highest and the lowest Debt(current US$) in 1972?
Provide a succinct answer. 4.94e+08. What is the difference between the highest and the lowest Debt(current US$) of 1973?
Your answer should be compact. 4.74e+08. 